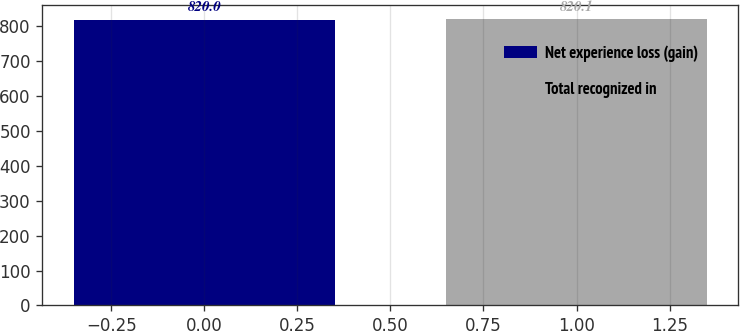<chart> <loc_0><loc_0><loc_500><loc_500><bar_chart><fcel>Net experience loss (gain)<fcel>Total recognized in<nl><fcel>820<fcel>820.1<nl></chart> 